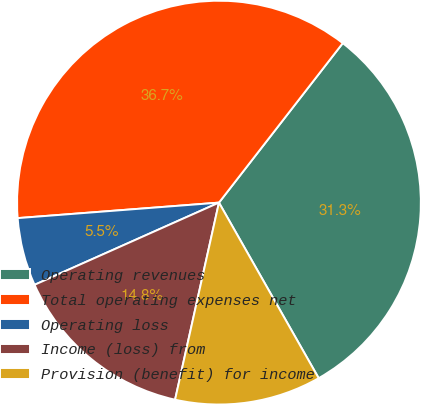Convert chart to OTSL. <chart><loc_0><loc_0><loc_500><loc_500><pie_chart><fcel>Operating revenues<fcel>Total operating expenses net<fcel>Operating loss<fcel>Income (loss) from<fcel>Provision (benefit) for income<nl><fcel>31.27%<fcel>36.73%<fcel>5.45%<fcel>14.84%<fcel>11.71%<nl></chart> 